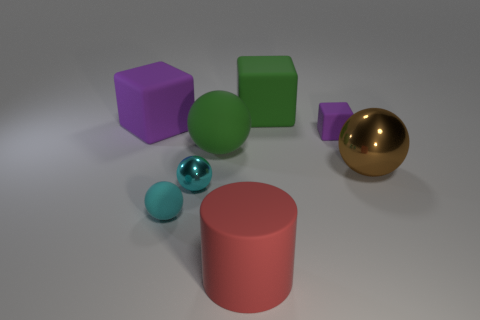What number of other things are the same color as the small rubber block?
Provide a succinct answer. 1. Are there fewer brown metallic balls that are in front of the green rubber block than large brown metallic objects in front of the large metallic sphere?
Give a very brief answer. No. How big is the matte object behind the cube that is to the left of the green object behind the large rubber ball?
Make the answer very short. Large. What is the size of the object that is both to the right of the green matte block and left of the big brown metallic object?
Provide a succinct answer. Small. What is the shape of the big green matte thing that is behind the purple cube that is in front of the large purple matte cube?
Offer a terse response. Cube. Are there any other things that are the same color as the small matte cube?
Make the answer very short. Yes. What is the shape of the large green object in front of the tiny rubber cube?
Keep it short and to the point. Sphere. There is a big thing that is both to the right of the red cylinder and on the left side of the brown metal object; what shape is it?
Your response must be concise. Cube. What number of cyan things are tiny shiny cylinders or tiny objects?
Make the answer very short. 2. Does the small sphere on the left side of the small shiny sphere have the same color as the big rubber ball?
Your answer should be very brief. No. 